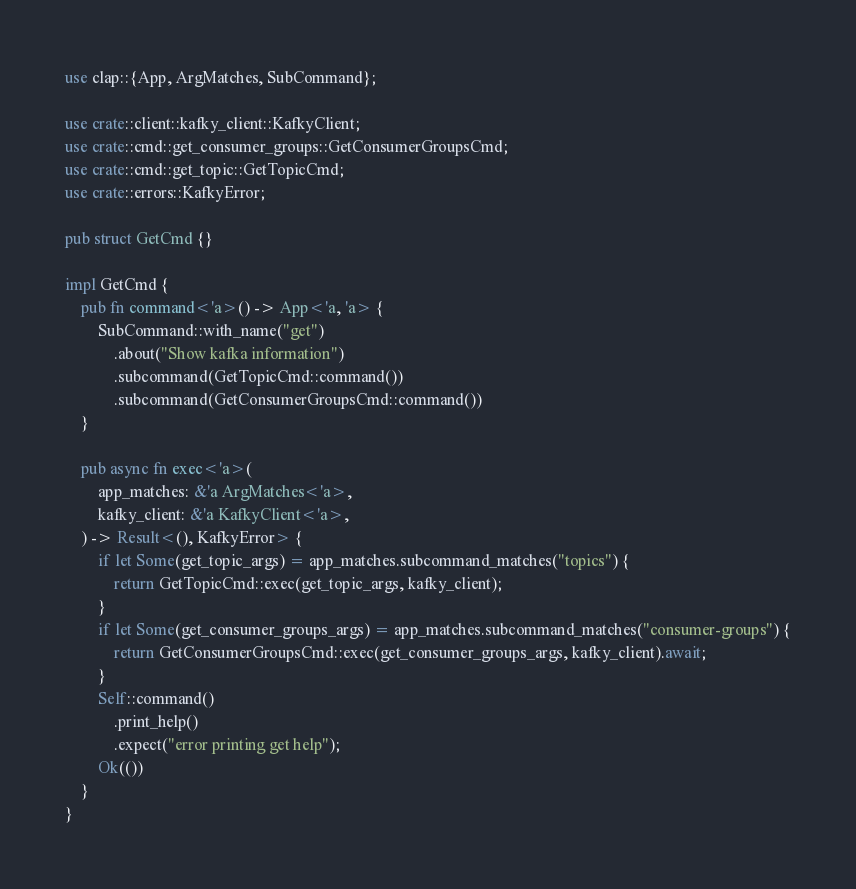<code> <loc_0><loc_0><loc_500><loc_500><_Rust_>use clap::{App, ArgMatches, SubCommand};

use crate::client::kafky_client::KafkyClient;
use crate::cmd::get_consumer_groups::GetConsumerGroupsCmd;
use crate::cmd::get_topic::GetTopicCmd;
use crate::errors::KafkyError;

pub struct GetCmd {}

impl GetCmd {
    pub fn command<'a>() -> App<'a, 'a> {
        SubCommand::with_name("get")
            .about("Show kafka information")
            .subcommand(GetTopicCmd::command())
            .subcommand(GetConsumerGroupsCmd::command())
    }

    pub async fn exec<'a>(
        app_matches: &'a ArgMatches<'a>,
        kafky_client: &'a KafkyClient<'a>,
    ) -> Result<(), KafkyError> {
        if let Some(get_topic_args) = app_matches.subcommand_matches("topics") {
            return GetTopicCmd::exec(get_topic_args, kafky_client);
        }
        if let Some(get_consumer_groups_args) = app_matches.subcommand_matches("consumer-groups") {
            return GetConsumerGroupsCmd::exec(get_consumer_groups_args, kafky_client).await;
        }
        Self::command()
            .print_help()
            .expect("error printing get help");
        Ok(())
    }
}
</code> 